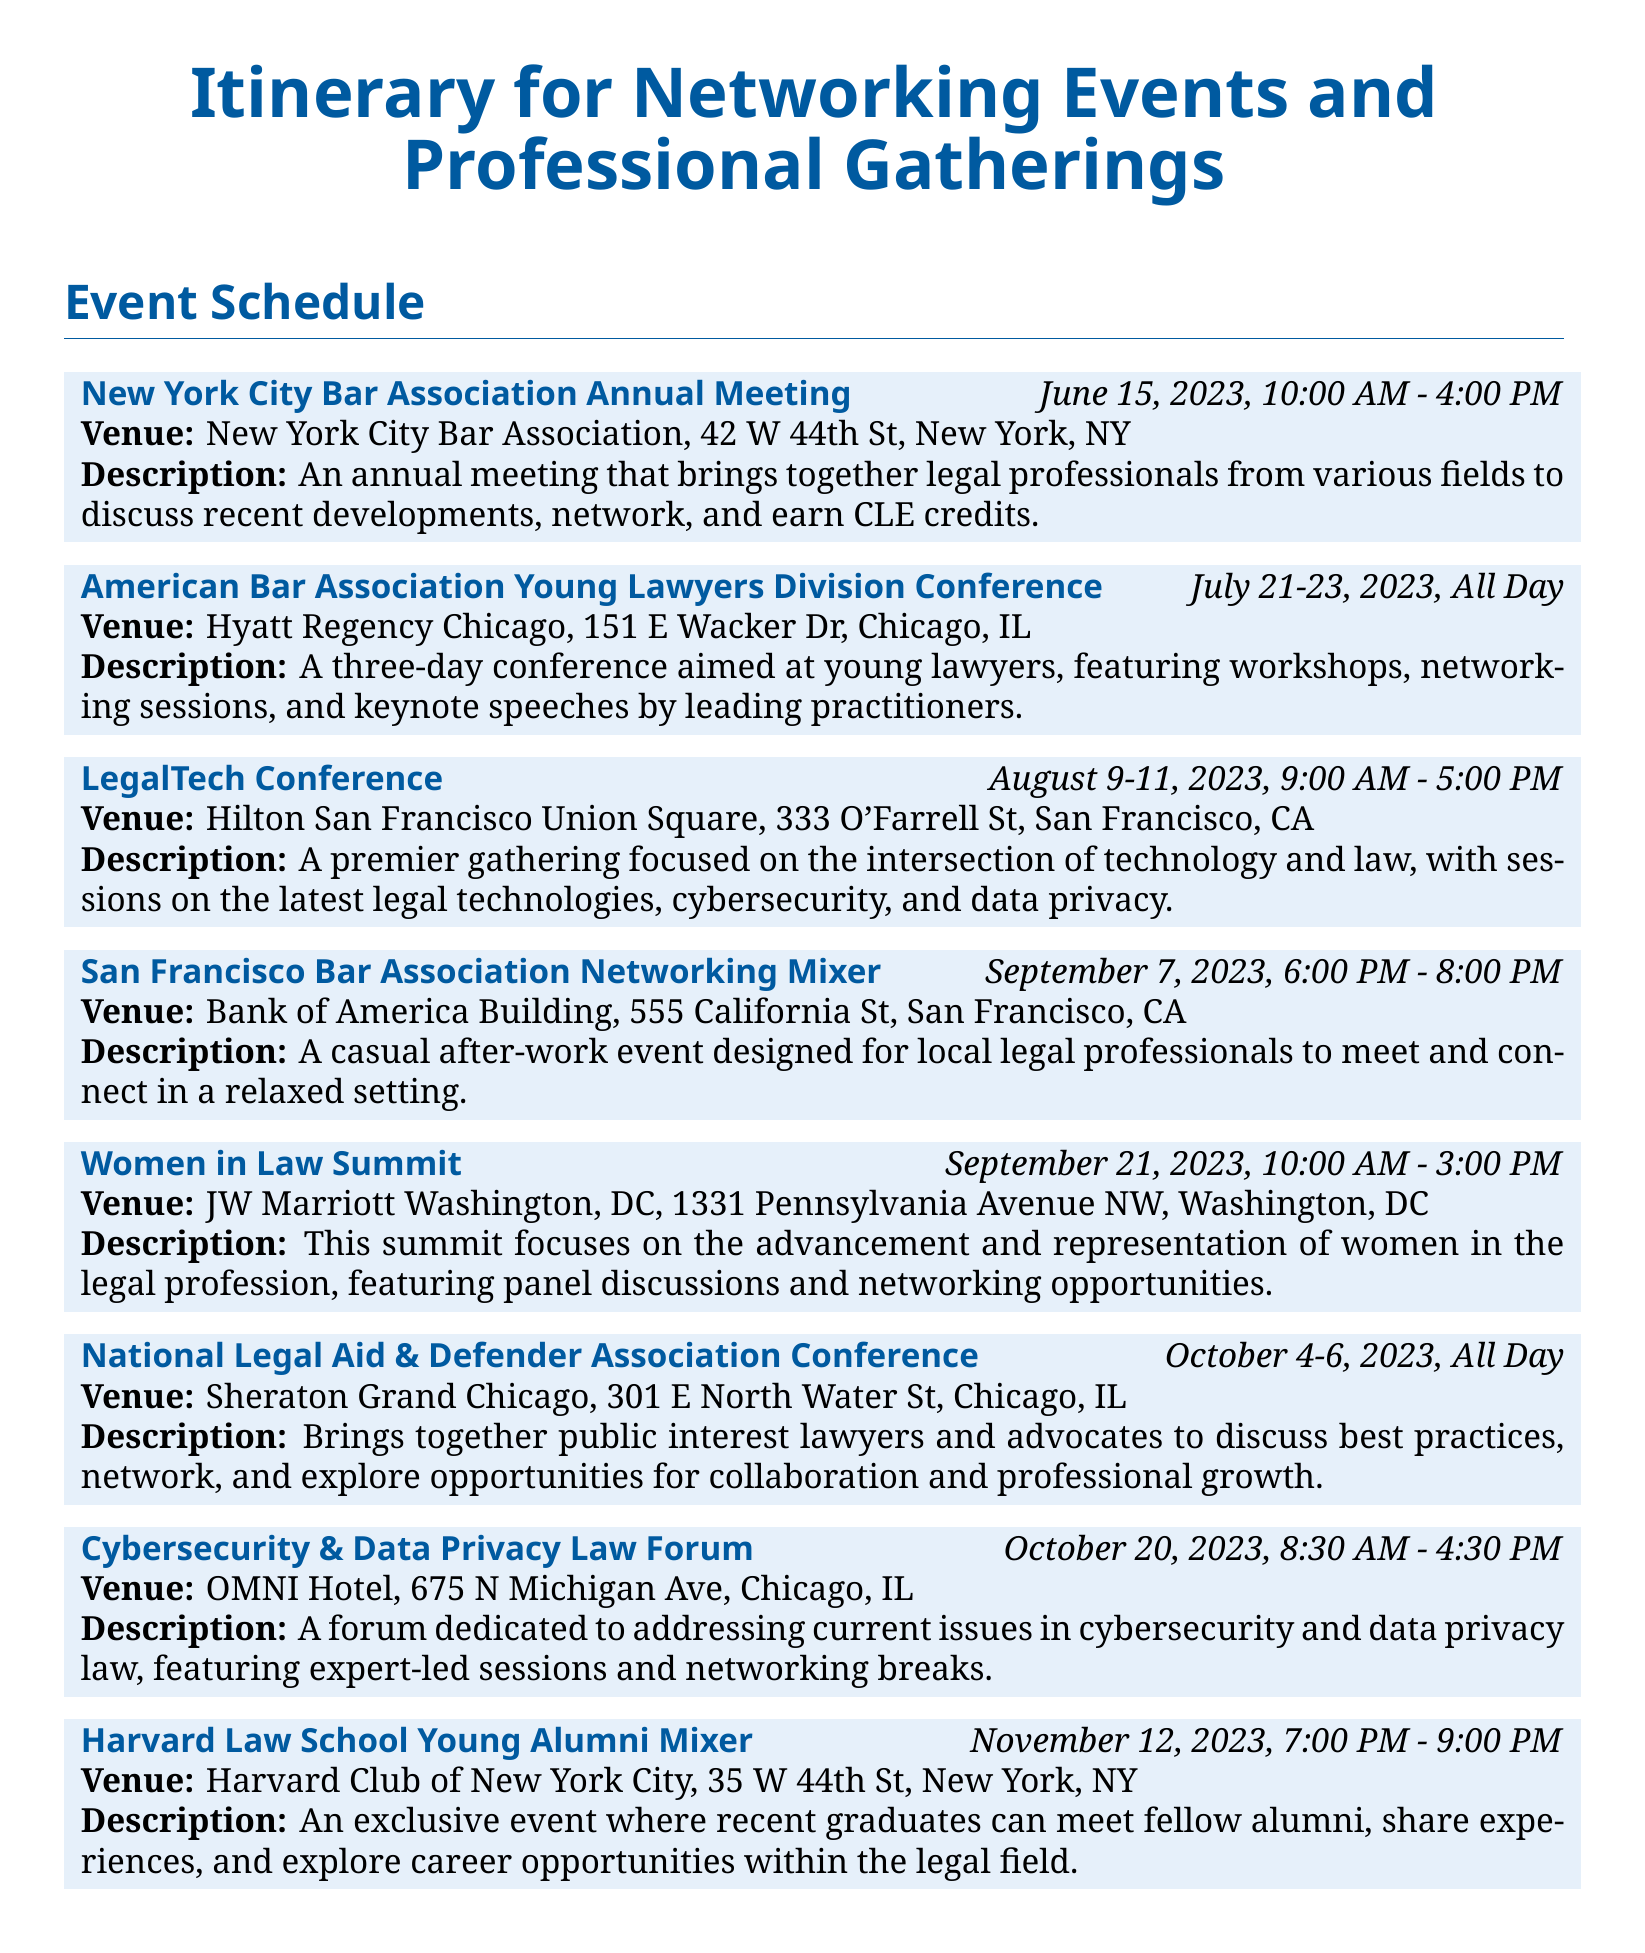What is the date of the New York City Bar Association Annual Meeting? The date is listed clearly in the itinerary as June 15, 2023.
Answer: June 15, 2023 What is the venue for the Women in Law Summit? The venue is specified in the event details of the Women in Law Summit.
Answer: JW Marriott Washington, DC How many days does the American Bar Association Young Lawyers Division Conference last? The duration of the conference is mentioned in the itinerary, indicating it lasts three days.
Answer: Three days What is the primary focus of the LegalTech Conference? The itinerary provides a description that outlines the main topics being discussed at the event.
Answer: Legal technologies What time does the Cybersecurity & Data Privacy Law Forum start? The itinerary specifies the starting time of the event.
Answer: 8:30 AM Name one of the purposes of the San Francisco Bar Association Networking Mixer. The description in the itinerary mentions its purpose which involves meeting local legal professionals.
Answer: Casual networking Where is the National Legal Aid & Defender Association Conference held? The location is provided within the details of the conference listing in the itinerary.
Answer: Sheraton Grand Chicago What is the date range for the National Legal Aid & Defender Association Conference? The itinerary clearly states the full date range for the conference.
Answer: October 4-6, 2023 What type of professionals attend the Harvard Law School Young Alumni Mixer? The event description specifies the target attendees of this particular mixer.
Answer: Recent graduates How long is the Women in Law Summit? The duration is indicated in the itinerary details for this specific event.
Answer: 5 hours 